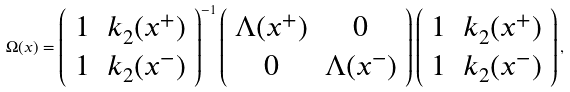Convert formula to latex. <formula><loc_0><loc_0><loc_500><loc_500>\Omega ( x ) = \left ( \begin{array} { c c } 1 & k _ { 2 } ( x ^ { + } ) \\ 1 & k _ { 2 } ( x ^ { - } ) \end{array} \right ) ^ { - 1 } \left ( \begin{array} { c c } \Lambda ( x ^ { + } ) & 0 \\ 0 & \Lambda ( x ^ { - } ) \end{array} \right ) \left ( \begin{array} { c c } 1 & k _ { 2 } ( x ^ { + } ) \\ 1 & k _ { 2 } ( x ^ { - } ) \end{array} \right ) ,</formula> 